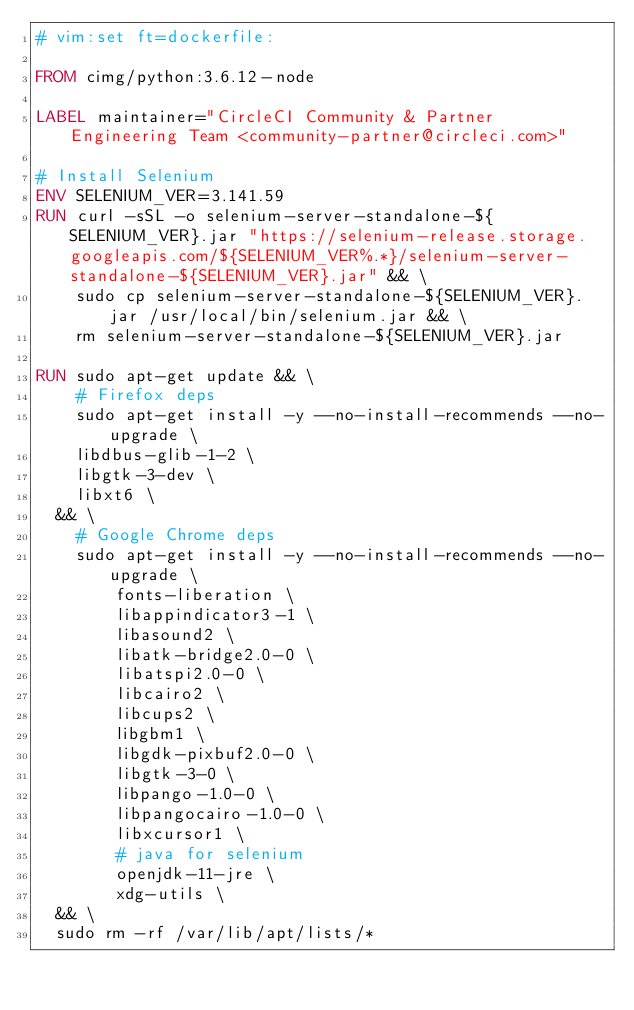<code> <loc_0><loc_0><loc_500><loc_500><_Dockerfile_># vim:set ft=dockerfile:

FROM cimg/python:3.6.12-node

LABEL maintainer="CircleCI Community & Partner Engineering Team <community-partner@circleci.com>"

# Install Selenium
ENV SELENIUM_VER=3.141.59
RUN curl -sSL -o selenium-server-standalone-${SELENIUM_VER}.jar "https://selenium-release.storage.googleapis.com/${SELENIUM_VER%.*}/selenium-server-standalone-${SELENIUM_VER}.jar" && \
    sudo cp selenium-server-standalone-${SELENIUM_VER}.jar /usr/local/bin/selenium.jar && \
    rm selenium-server-standalone-${SELENIUM_VER}.jar

RUN sudo apt-get update && \
    # Firefox deps
    sudo apt-get install -y --no-install-recommends --no-upgrade \
		libdbus-glib-1-2 \
		libgtk-3-dev \
		libxt6 \
	&& \
    # Google Chrome deps
    sudo apt-get install -y --no-install-recommends --no-upgrade \
        fonts-liberation \
        libappindicator3-1 \
        libasound2 \
        libatk-bridge2.0-0 \
        libatspi2.0-0 \
        libcairo2 \
        libcups2 \
        libgbm1 \
        libgdk-pixbuf2.0-0 \
        libgtk-3-0 \
        libpango-1.0-0 \
        libpangocairo-1.0-0 \
        libxcursor1 \
        # java for selenium
        openjdk-11-jre \
        xdg-utils \
	&& \
	sudo rm -rf /var/lib/apt/lists/*
</code> 